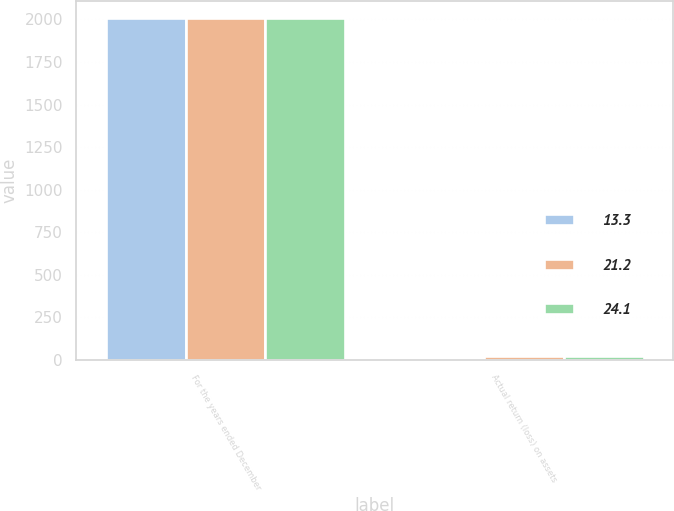Convert chart to OTSL. <chart><loc_0><loc_0><loc_500><loc_500><stacked_bar_chart><ecel><fcel>For the years ended December<fcel>Actual return (loss) on assets<nl><fcel>13.3<fcel>2010<fcel>13.3<nl><fcel>21.2<fcel>2009<fcel>21.2<nl><fcel>24.1<fcel>2008<fcel>24.1<nl></chart> 